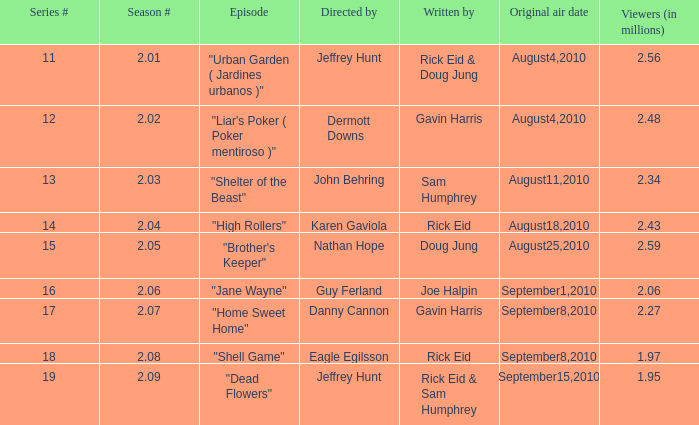What is the series minimum if the season number is 2.08? 18.0. 